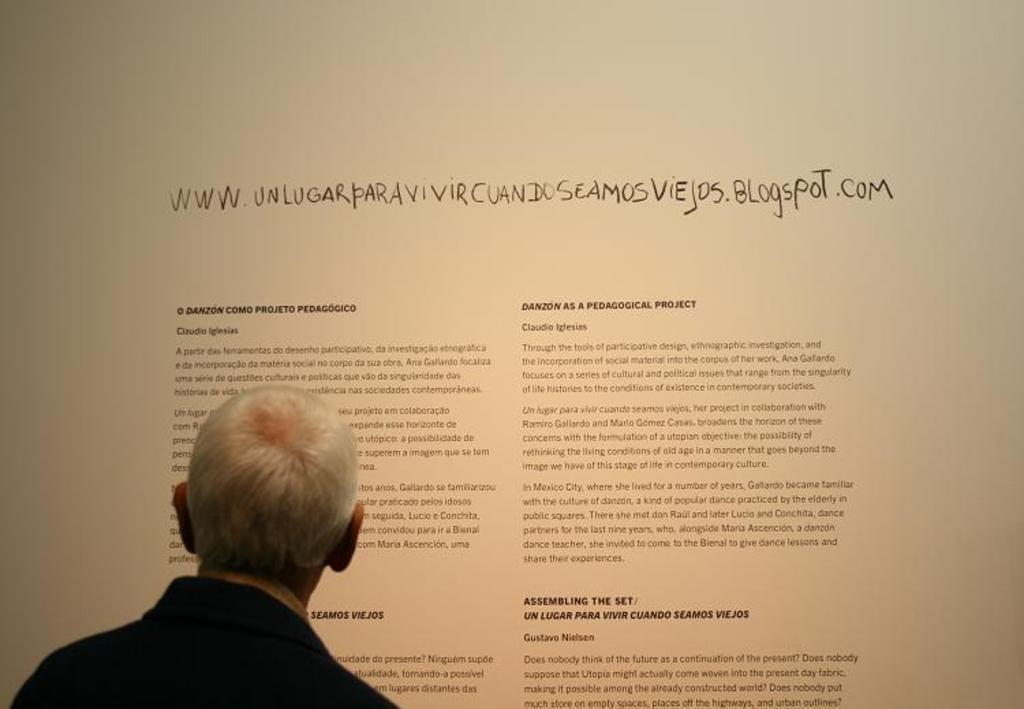What is the main subject of the image? The main subject of the image is an old man's head. What is the old man standing in front of? The old man is standing in front of a board with writing. Can you describe the board in the image? The board has writing on it. What type of fowl can be seen perched on the old man's shoulder in the image? There is no fowl present on the old man's shoulder in the image. 